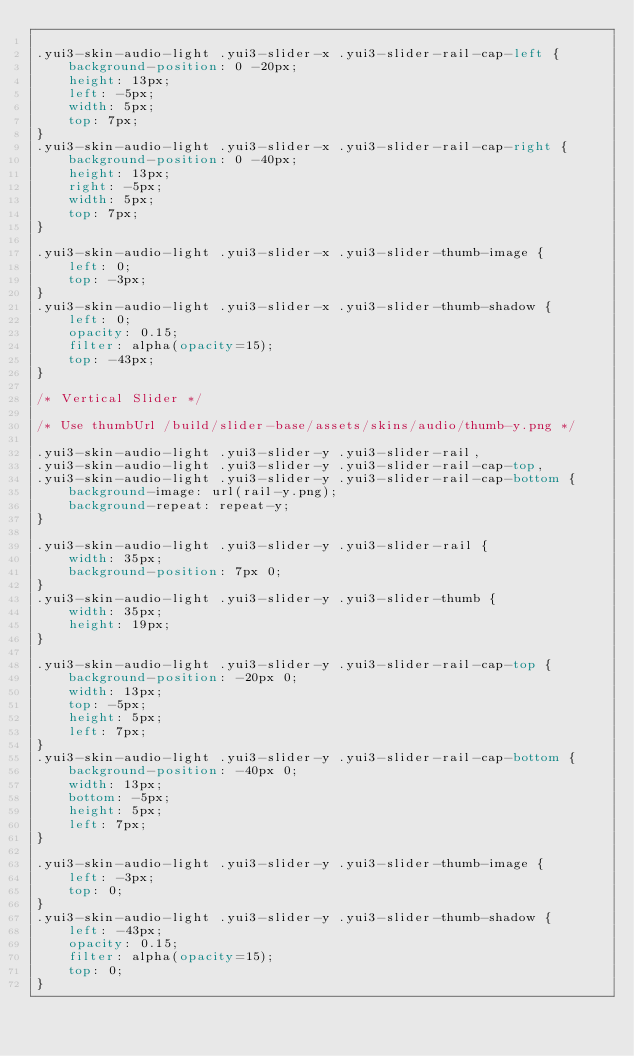Convert code to text. <code><loc_0><loc_0><loc_500><loc_500><_CSS_>
.yui3-skin-audio-light .yui3-slider-x .yui3-slider-rail-cap-left {
    background-position: 0 -20px;
    height: 13px;
    left: -5px;
    width: 5px;
    top: 7px;
}
.yui3-skin-audio-light .yui3-slider-x .yui3-slider-rail-cap-right {
    background-position: 0 -40px;
    height: 13px;
    right: -5px;
    width: 5px;
    top: 7px;
}

.yui3-skin-audio-light .yui3-slider-x .yui3-slider-thumb-image {
    left: 0;
    top: -3px;
}
.yui3-skin-audio-light .yui3-slider-x .yui3-slider-thumb-shadow {
    left: 0;
    opacity: 0.15;
    filter: alpha(opacity=15);
    top: -43px;
}

/* Vertical Slider */

/* Use thumbUrl /build/slider-base/assets/skins/audio/thumb-y.png */

.yui3-skin-audio-light .yui3-slider-y .yui3-slider-rail,
.yui3-skin-audio-light .yui3-slider-y .yui3-slider-rail-cap-top,
.yui3-skin-audio-light .yui3-slider-y .yui3-slider-rail-cap-bottom {
    background-image: url(rail-y.png);
    background-repeat: repeat-y;
}

.yui3-skin-audio-light .yui3-slider-y .yui3-slider-rail {
    width: 35px;
    background-position: 7px 0;
}
.yui3-skin-audio-light .yui3-slider-y .yui3-slider-thumb {
    width: 35px;
    height: 19px;
}

.yui3-skin-audio-light .yui3-slider-y .yui3-slider-rail-cap-top {
    background-position: -20px 0;
    width: 13px;
    top: -5px;
    height: 5px;
    left: 7px;
}
.yui3-skin-audio-light .yui3-slider-y .yui3-slider-rail-cap-bottom {
    background-position: -40px 0;
    width: 13px;
    bottom: -5px;
    height: 5px;
    left: 7px;
}

.yui3-skin-audio-light .yui3-slider-y .yui3-slider-thumb-image {
    left: -3px;
    top: 0;
}
.yui3-skin-audio-light .yui3-slider-y .yui3-slider-thumb-shadow {
    left: -43px;
    opacity: 0.15;
    filter: alpha(opacity=15);
    top: 0;
}
</code> 